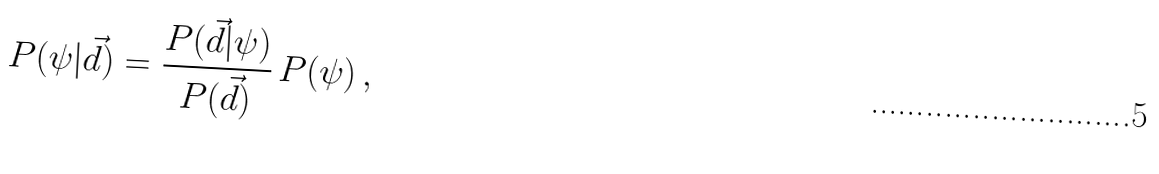Convert formula to latex. <formula><loc_0><loc_0><loc_500><loc_500>P ( \psi | \vec { d } ) = \frac { P ( \vec { d } | \psi ) } { P ( \vec { d } ) } \, P ( \psi ) \, ,</formula> 